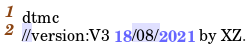<code> <loc_0><loc_0><loc_500><loc_500><_Perl_>dtmc
//version:V3 18/08/2021 by XZ.
</code> 